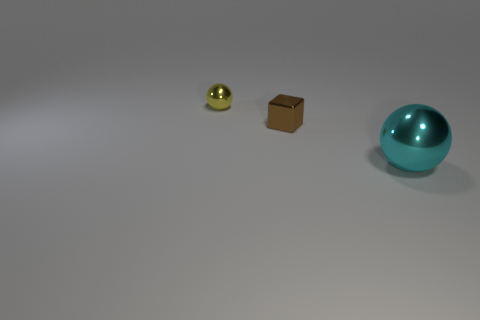There is a shiny object that is behind the large cyan object and right of the tiny yellow thing; what color is it?
Ensure brevity in your answer.  Brown. What number of objects are green metallic cubes or small metal things in front of the tiny yellow metal ball?
Your response must be concise. 1. There is a ball that is behind the sphere on the right side of the ball to the left of the cyan metal sphere; what is its material?
Offer a terse response. Metal. Is there anything else that has the same material as the brown object?
Your answer should be very brief. Yes. There is a sphere on the left side of the large metal object; is it the same color as the metallic block?
Make the answer very short. No. How many blue objects are blocks or big cubes?
Your answer should be very brief. 0. How many other objects are there of the same shape as the small brown metallic thing?
Your answer should be very brief. 0. Is the material of the brown block the same as the yellow sphere?
Provide a short and direct response. Yes. What is the thing that is behind the large metallic ball and on the right side of the yellow object made of?
Provide a short and direct response. Metal. There is a ball that is behind the big sphere; what color is it?
Give a very brief answer. Yellow. 